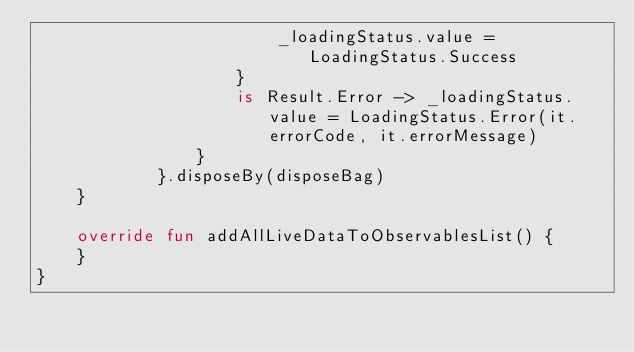Convert code to text. <code><loc_0><loc_0><loc_500><loc_500><_Kotlin_>                        _loadingStatus.value = LoadingStatus.Success
                    }
                    is Result.Error -> _loadingStatus.value = LoadingStatus.Error(it.errorCode, it.errorMessage)
                }
            }.disposeBy(disposeBag)
    }

    override fun addAllLiveDataToObservablesList() {
    }
}</code> 